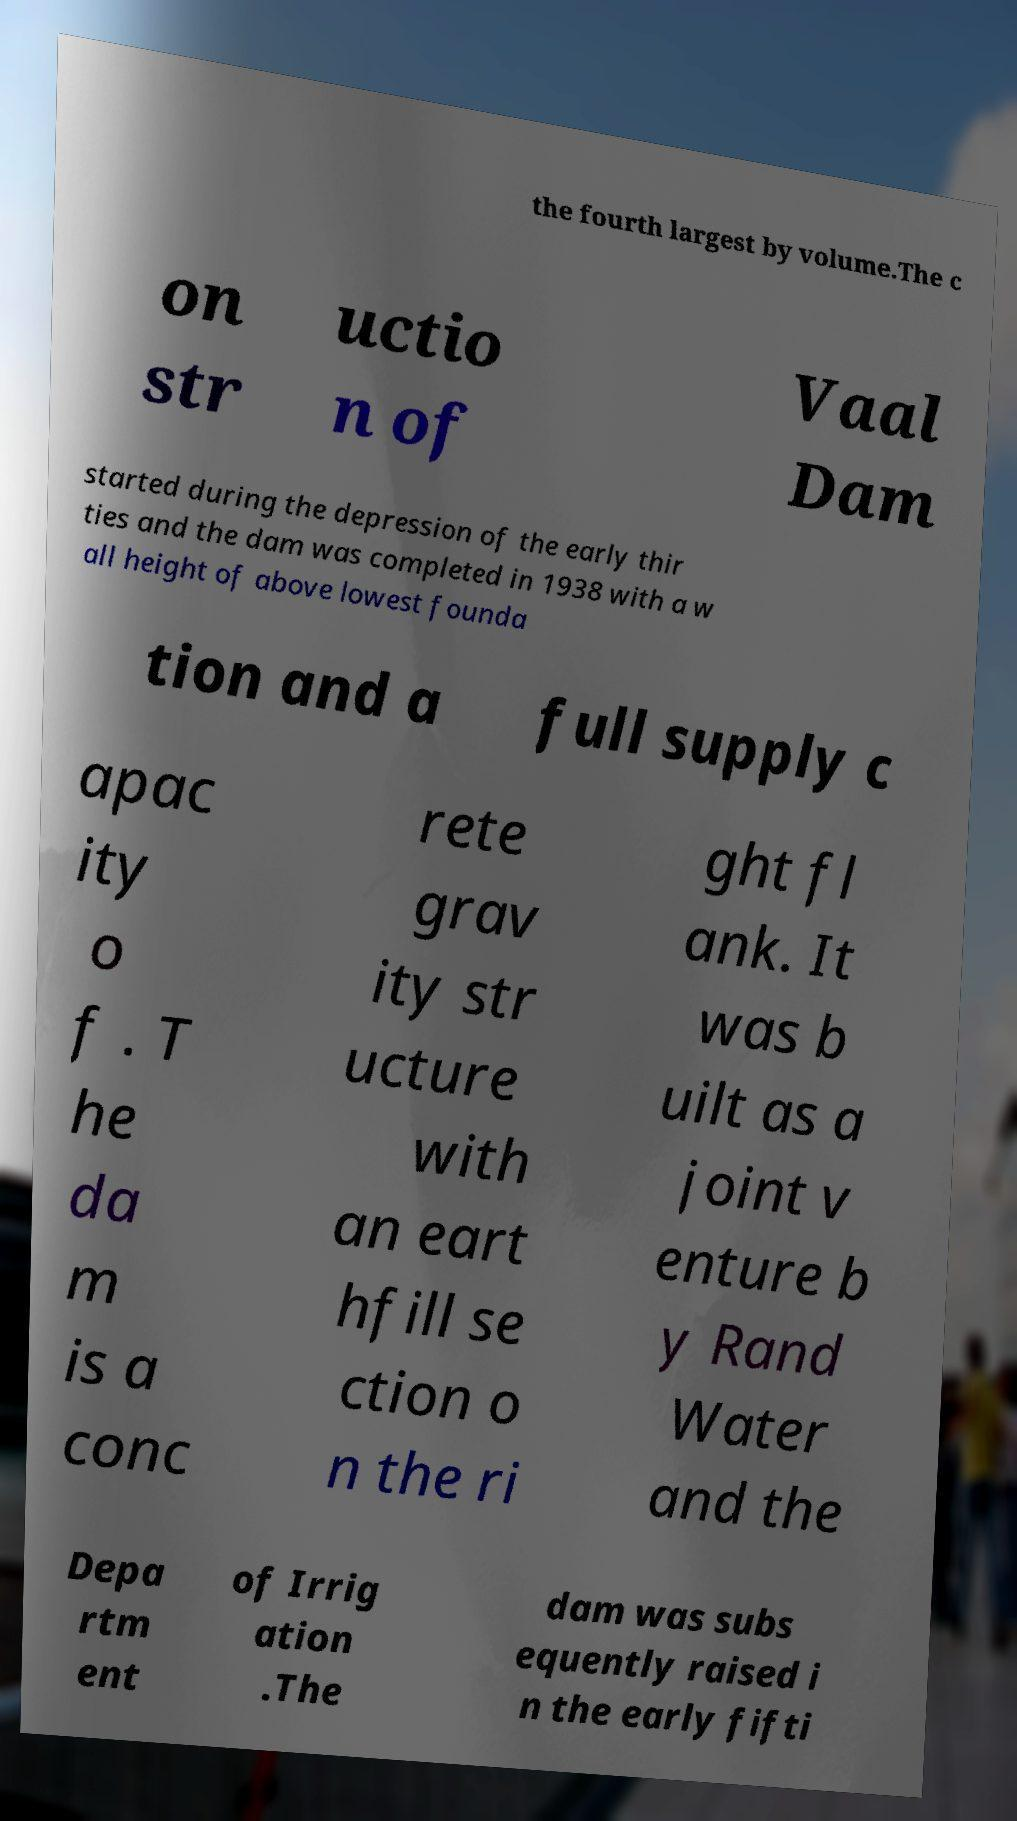Could you assist in decoding the text presented in this image and type it out clearly? the fourth largest by volume.The c on str uctio n of Vaal Dam started during the depression of the early thir ties and the dam was completed in 1938 with a w all height of above lowest founda tion and a full supply c apac ity o f . T he da m is a conc rete grav ity str ucture with an eart hfill se ction o n the ri ght fl ank. It was b uilt as a joint v enture b y Rand Water and the Depa rtm ent of Irrig ation .The dam was subs equently raised i n the early fifti 